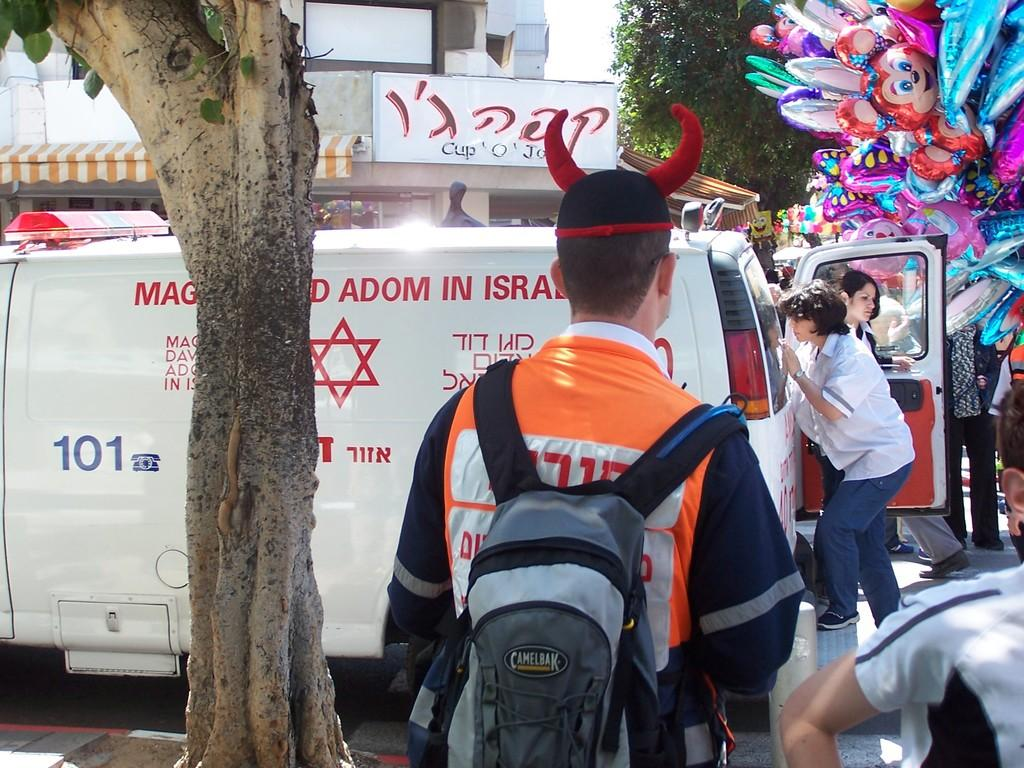Who or what can be seen in the image? There are people in the image. What type of natural elements are present in the image? There are trees in the image. What type of vehicle is visible in the image? There is a van in the image. What additional decorative elements can be seen in the image? Balloons are present in the image. What type of establishment is featured in the image? There is a shop in the image. How many babies are being given a haircut in the image? There are no babies or haircuts present in the image. What type of cover is used to protect the van from the sun in the image? There is no cover visible on the van in the image. 